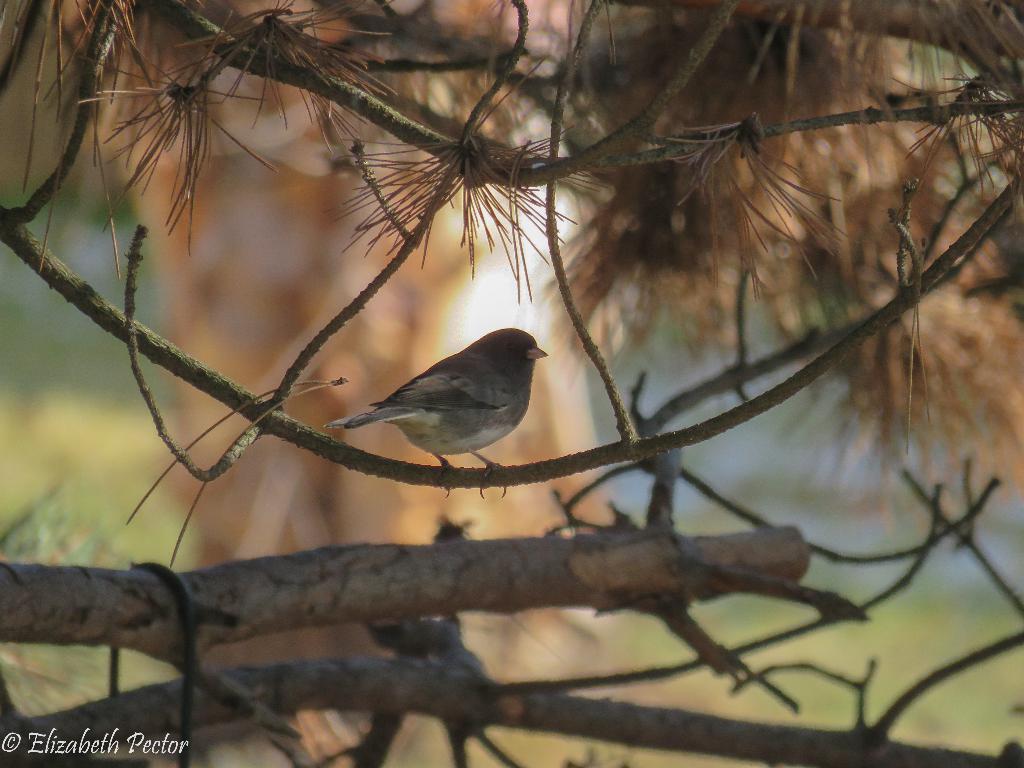How would you summarize this image in a sentence or two? This image is taken outdoors. In the background there is a ground with grass on it and there is a tree. In the middle of the image there is a bird on the stem. 